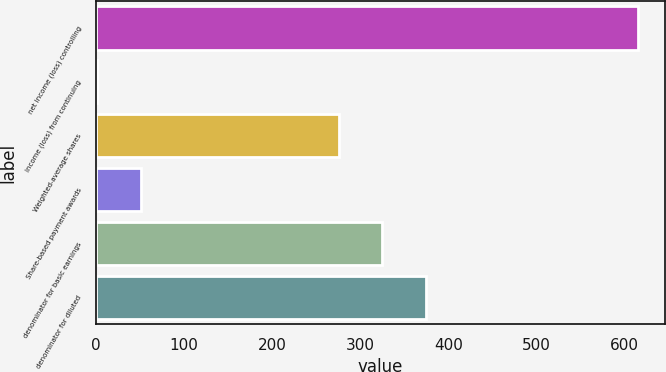Convert chart. <chart><loc_0><loc_0><loc_500><loc_500><bar_chart><fcel>net income (loss) controlling<fcel>income (loss) from continuing<fcel>Weighted-average shares<fcel>Share-based payment awards<fcel>denominator for basic earnings<fcel>denominator for diluted<nl><fcel>614.61<fcel>1.72<fcel>276<fcel>50.89<fcel>325.17<fcel>374.34<nl></chart> 